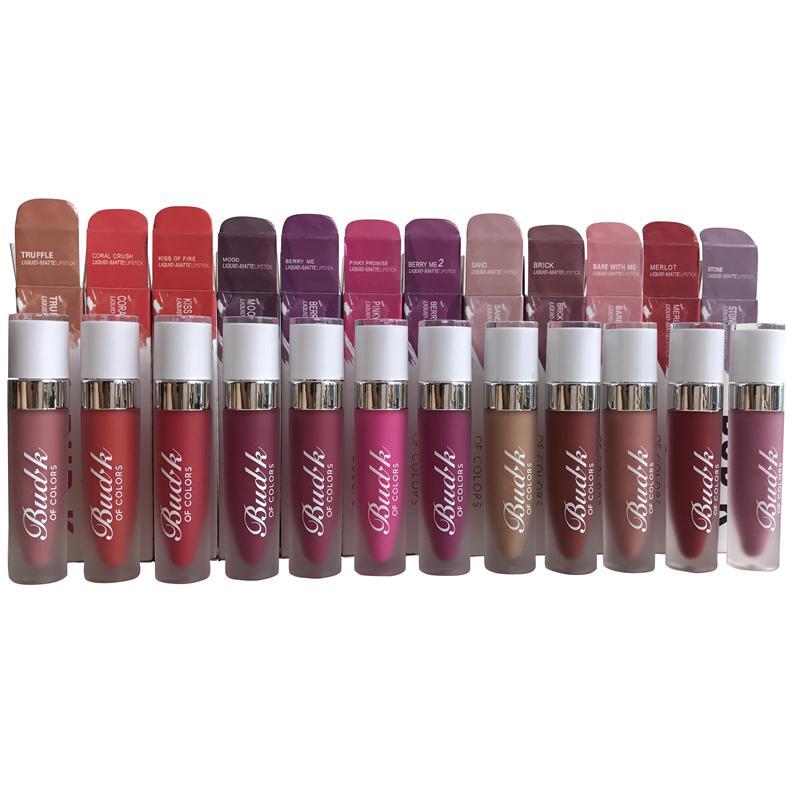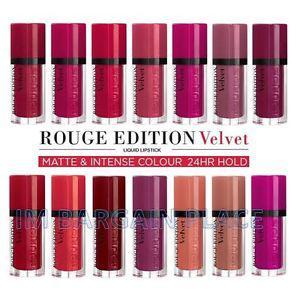The first image is the image on the left, the second image is the image on the right. Assess this claim about the two images: "There are at least eleven lipsticks in the image on the left.". Correct or not? Answer yes or no. Yes. The first image is the image on the left, the second image is the image on the right. Evaluate the accuracy of this statement regarding the images: "Right image shows two horizontal rows of the same product style.". Is it true? Answer yes or no. Yes. 